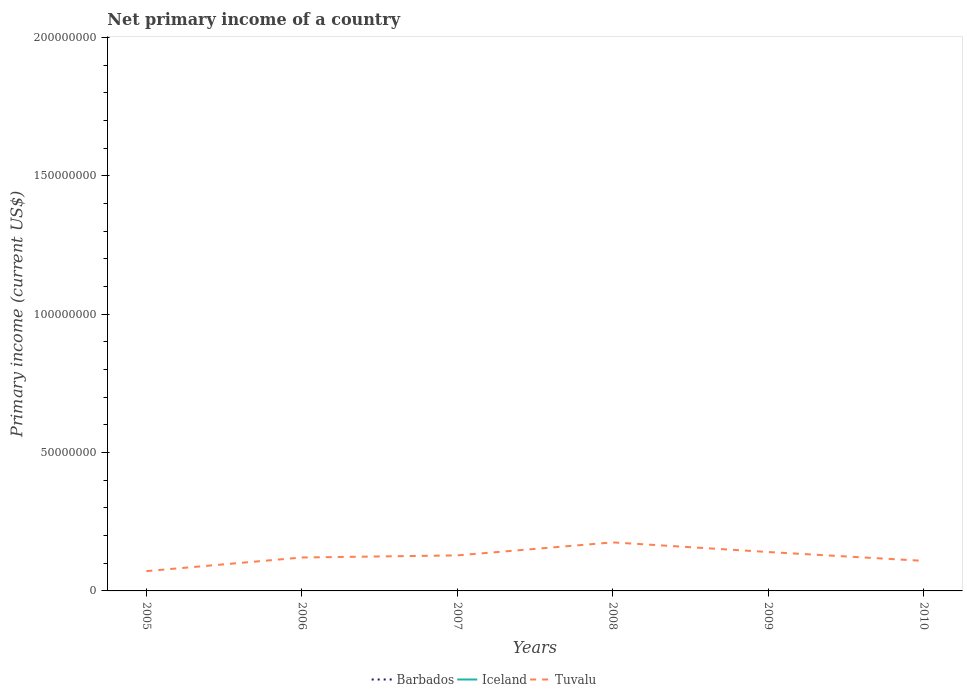How many different coloured lines are there?
Give a very brief answer. 1. Does the line corresponding to Iceland intersect with the line corresponding to Tuvalu?
Your response must be concise. No. Is the number of lines equal to the number of legend labels?
Your response must be concise. No. What is the total primary income in Tuvalu in the graph?
Your answer should be compact. -1.98e+06. What is the difference between the highest and the second highest primary income in Tuvalu?
Make the answer very short. 1.04e+07. How many lines are there?
Offer a very short reply. 1. What is the difference between two consecutive major ticks on the Y-axis?
Make the answer very short. 5.00e+07. Does the graph contain grids?
Give a very brief answer. No. What is the title of the graph?
Your answer should be compact. Net primary income of a country. What is the label or title of the Y-axis?
Your answer should be compact. Primary income (current US$). What is the Primary income (current US$) in Tuvalu in 2005?
Ensure brevity in your answer.  7.15e+06. What is the Primary income (current US$) in Barbados in 2006?
Offer a terse response. 0. What is the Primary income (current US$) in Tuvalu in 2006?
Provide a succinct answer. 1.21e+07. What is the Primary income (current US$) of Iceland in 2007?
Offer a terse response. 0. What is the Primary income (current US$) of Tuvalu in 2007?
Ensure brevity in your answer.  1.28e+07. What is the Primary income (current US$) of Iceland in 2008?
Offer a terse response. 0. What is the Primary income (current US$) in Tuvalu in 2008?
Make the answer very short. 1.75e+07. What is the Primary income (current US$) of Tuvalu in 2009?
Provide a succinct answer. 1.41e+07. What is the Primary income (current US$) in Iceland in 2010?
Your answer should be very brief. 0. What is the Primary income (current US$) of Tuvalu in 2010?
Your answer should be very brief. 1.09e+07. Across all years, what is the maximum Primary income (current US$) of Tuvalu?
Give a very brief answer. 1.75e+07. Across all years, what is the minimum Primary income (current US$) of Tuvalu?
Give a very brief answer. 7.15e+06. What is the total Primary income (current US$) of Barbados in the graph?
Make the answer very short. 0. What is the total Primary income (current US$) in Tuvalu in the graph?
Provide a short and direct response. 7.45e+07. What is the difference between the Primary income (current US$) of Tuvalu in 2005 and that in 2006?
Offer a very short reply. -4.93e+06. What is the difference between the Primary income (current US$) of Tuvalu in 2005 and that in 2007?
Provide a succinct answer. -5.69e+06. What is the difference between the Primary income (current US$) in Tuvalu in 2005 and that in 2008?
Provide a short and direct response. -1.04e+07. What is the difference between the Primary income (current US$) of Tuvalu in 2005 and that in 2009?
Give a very brief answer. -6.91e+06. What is the difference between the Primary income (current US$) of Tuvalu in 2005 and that in 2010?
Offer a terse response. -3.71e+06. What is the difference between the Primary income (current US$) of Tuvalu in 2006 and that in 2007?
Keep it short and to the point. -7.59e+05. What is the difference between the Primary income (current US$) in Tuvalu in 2006 and that in 2008?
Ensure brevity in your answer.  -5.46e+06. What is the difference between the Primary income (current US$) in Tuvalu in 2006 and that in 2009?
Give a very brief answer. -1.98e+06. What is the difference between the Primary income (current US$) of Tuvalu in 2006 and that in 2010?
Keep it short and to the point. 1.22e+06. What is the difference between the Primary income (current US$) in Tuvalu in 2007 and that in 2008?
Offer a very short reply. -4.70e+06. What is the difference between the Primary income (current US$) in Tuvalu in 2007 and that in 2009?
Provide a succinct answer. -1.22e+06. What is the difference between the Primary income (current US$) in Tuvalu in 2007 and that in 2010?
Provide a short and direct response. 1.98e+06. What is the difference between the Primary income (current US$) of Tuvalu in 2008 and that in 2009?
Make the answer very short. 3.48e+06. What is the difference between the Primary income (current US$) of Tuvalu in 2008 and that in 2010?
Your answer should be very brief. 6.68e+06. What is the difference between the Primary income (current US$) in Tuvalu in 2009 and that in 2010?
Give a very brief answer. 3.20e+06. What is the average Primary income (current US$) of Barbados per year?
Offer a terse response. 0. What is the average Primary income (current US$) of Iceland per year?
Offer a terse response. 0. What is the average Primary income (current US$) in Tuvalu per year?
Give a very brief answer. 1.24e+07. What is the ratio of the Primary income (current US$) of Tuvalu in 2005 to that in 2006?
Your answer should be compact. 0.59. What is the ratio of the Primary income (current US$) of Tuvalu in 2005 to that in 2007?
Provide a short and direct response. 0.56. What is the ratio of the Primary income (current US$) in Tuvalu in 2005 to that in 2008?
Offer a terse response. 0.41. What is the ratio of the Primary income (current US$) in Tuvalu in 2005 to that in 2009?
Give a very brief answer. 0.51. What is the ratio of the Primary income (current US$) of Tuvalu in 2005 to that in 2010?
Offer a terse response. 0.66. What is the ratio of the Primary income (current US$) of Tuvalu in 2006 to that in 2007?
Your response must be concise. 0.94. What is the ratio of the Primary income (current US$) of Tuvalu in 2006 to that in 2008?
Your answer should be very brief. 0.69. What is the ratio of the Primary income (current US$) of Tuvalu in 2006 to that in 2009?
Ensure brevity in your answer.  0.86. What is the ratio of the Primary income (current US$) of Tuvalu in 2006 to that in 2010?
Offer a terse response. 1.11. What is the ratio of the Primary income (current US$) of Tuvalu in 2007 to that in 2008?
Your answer should be very brief. 0.73. What is the ratio of the Primary income (current US$) in Tuvalu in 2007 to that in 2009?
Provide a short and direct response. 0.91. What is the ratio of the Primary income (current US$) in Tuvalu in 2007 to that in 2010?
Provide a succinct answer. 1.18. What is the ratio of the Primary income (current US$) in Tuvalu in 2008 to that in 2009?
Offer a terse response. 1.25. What is the ratio of the Primary income (current US$) in Tuvalu in 2008 to that in 2010?
Ensure brevity in your answer.  1.61. What is the ratio of the Primary income (current US$) of Tuvalu in 2009 to that in 2010?
Provide a succinct answer. 1.29. What is the difference between the highest and the second highest Primary income (current US$) in Tuvalu?
Give a very brief answer. 3.48e+06. What is the difference between the highest and the lowest Primary income (current US$) in Tuvalu?
Your answer should be very brief. 1.04e+07. 